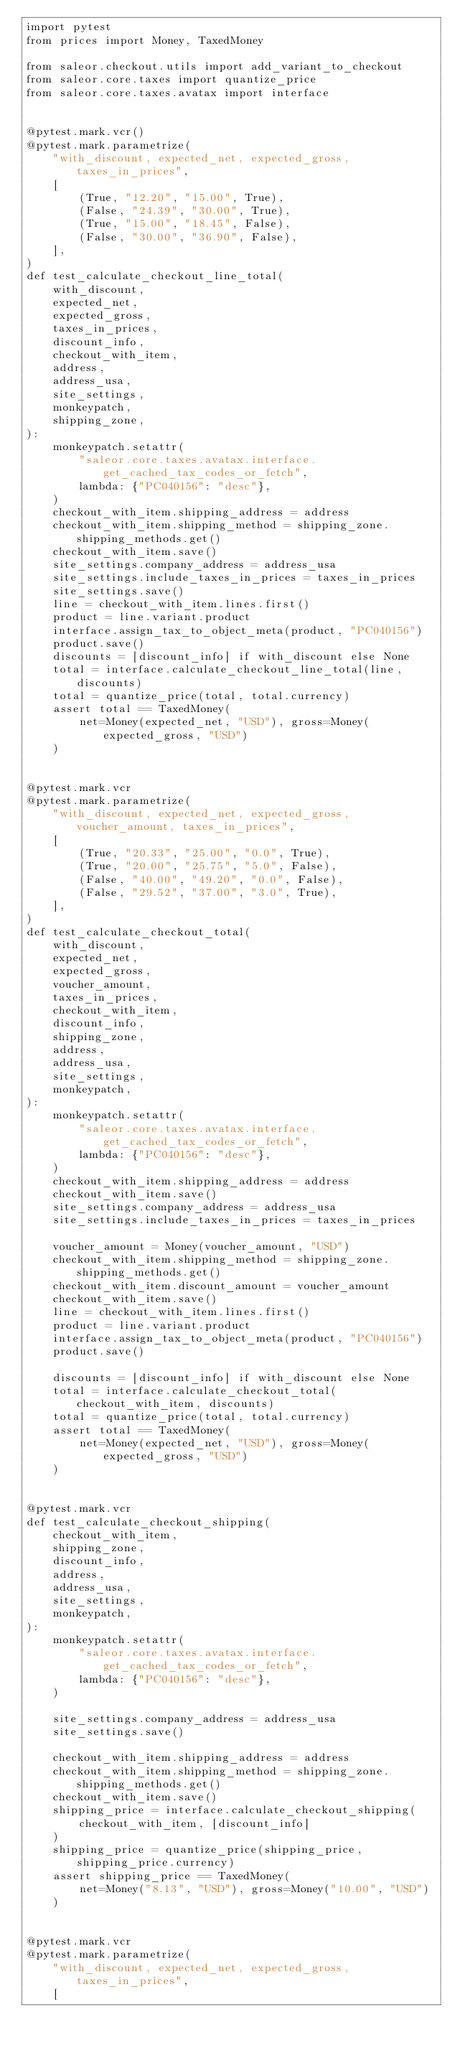<code> <loc_0><loc_0><loc_500><loc_500><_Python_>import pytest
from prices import Money, TaxedMoney

from saleor.checkout.utils import add_variant_to_checkout
from saleor.core.taxes import quantize_price
from saleor.core.taxes.avatax import interface


@pytest.mark.vcr()
@pytest.mark.parametrize(
    "with_discount, expected_net, expected_gross, taxes_in_prices",
    [
        (True, "12.20", "15.00", True),
        (False, "24.39", "30.00", True),
        (True, "15.00", "18.45", False),
        (False, "30.00", "36.90", False),
    ],
)
def test_calculate_checkout_line_total(
    with_discount,
    expected_net,
    expected_gross,
    taxes_in_prices,
    discount_info,
    checkout_with_item,
    address,
    address_usa,
    site_settings,
    monkeypatch,
    shipping_zone,
):
    monkeypatch.setattr(
        "saleor.core.taxes.avatax.interface.get_cached_tax_codes_or_fetch",
        lambda: {"PC040156": "desc"},
    )
    checkout_with_item.shipping_address = address
    checkout_with_item.shipping_method = shipping_zone.shipping_methods.get()
    checkout_with_item.save()
    site_settings.company_address = address_usa
    site_settings.include_taxes_in_prices = taxes_in_prices
    site_settings.save()
    line = checkout_with_item.lines.first()
    product = line.variant.product
    interface.assign_tax_to_object_meta(product, "PC040156")
    product.save()
    discounts = [discount_info] if with_discount else None
    total = interface.calculate_checkout_line_total(line, discounts)
    total = quantize_price(total, total.currency)
    assert total == TaxedMoney(
        net=Money(expected_net, "USD"), gross=Money(expected_gross, "USD")
    )


@pytest.mark.vcr
@pytest.mark.parametrize(
    "with_discount, expected_net, expected_gross, voucher_amount, taxes_in_prices",
    [
        (True, "20.33", "25.00", "0.0", True),
        (True, "20.00", "25.75", "5.0", False),
        (False, "40.00", "49.20", "0.0", False),
        (False, "29.52", "37.00", "3.0", True),
    ],
)
def test_calculate_checkout_total(
    with_discount,
    expected_net,
    expected_gross,
    voucher_amount,
    taxes_in_prices,
    checkout_with_item,
    discount_info,
    shipping_zone,
    address,
    address_usa,
    site_settings,
    monkeypatch,
):
    monkeypatch.setattr(
        "saleor.core.taxes.avatax.interface.get_cached_tax_codes_or_fetch",
        lambda: {"PC040156": "desc"},
    )
    checkout_with_item.shipping_address = address
    checkout_with_item.save()
    site_settings.company_address = address_usa
    site_settings.include_taxes_in_prices = taxes_in_prices

    voucher_amount = Money(voucher_amount, "USD")
    checkout_with_item.shipping_method = shipping_zone.shipping_methods.get()
    checkout_with_item.discount_amount = voucher_amount
    checkout_with_item.save()
    line = checkout_with_item.lines.first()
    product = line.variant.product
    interface.assign_tax_to_object_meta(product, "PC040156")
    product.save()

    discounts = [discount_info] if with_discount else None
    total = interface.calculate_checkout_total(checkout_with_item, discounts)
    total = quantize_price(total, total.currency)
    assert total == TaxedMoney(
        net=Money(expected_net, "USD"), gross=Money(expected_gross, "USD")
    )


@pytest.mark.vcr
def test_calculate_checkout_shipping(
    checkout_with_item,
    shipping_zone,
    discount_info,
    address,
    address_usa,
    site_settings,
    monkeypatch,
):
    monkeypatch.setattr(
        "saleor.core.taxes.avatax.interface.get_cached_tax_codes_or_fetch",
        lambda: {"PC040156": "desc"},
    )

    site_settings.company_address = address_usa
    site_settings.save()

    checkout_with_item.shipping_address = address
    checkout_with_item.shipping_method = shipping_zone.shipping_methods.get()
    checkout_with_item.save()
    shipping_price = interface.calculate_checkout_shipping(
        checkout_with_item, [discount_info]
    )
    shipping_price = quantize_price(shipping_price, shipping_price.currency)
    assert shipping_price == TaxedMoney(
        net=Money("8.13", "USD"), gross=Money("10.00", "USD")
    )


@pytest.mark.vcr
@pytest.mark.parametrize(
    "with_discount, expected_net, expected_gross, taxes_in_prices",
    [</code> 